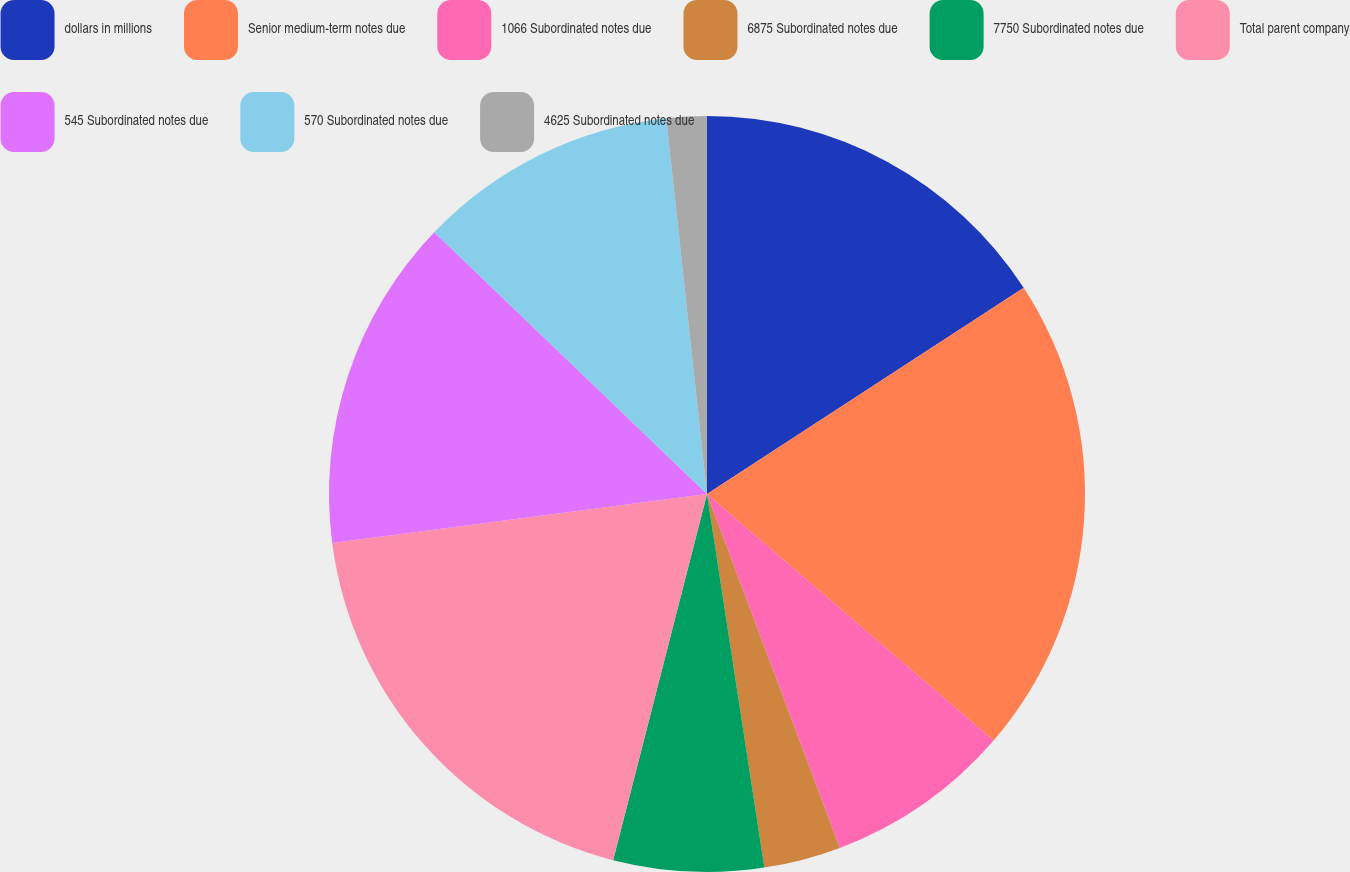Convert chart to OTSL. <chart><loc_0><loc_0><loc_500><loc_500><pie_chart><fcel>dollars in millions<fcel>Senior medium-term notes due<fcel>1066 Subordinated notes due<fcel>6875 Subordinated notes due<fcel>7750 Subordinated notes due<fcel>Total parent company<fcel>545 Subordinated notes due<fcel>570 Subordinated notes due<fcel>4625 Subordinated notes due<nl><fcel>15.81%<fcel>20.5%<fcel>7.98%<fcel>3.29%<fcel>6.42%<fcel>18.94%<fcel>14.24%<fcel>11.11%<fcel>1.72%<nl></chart> 